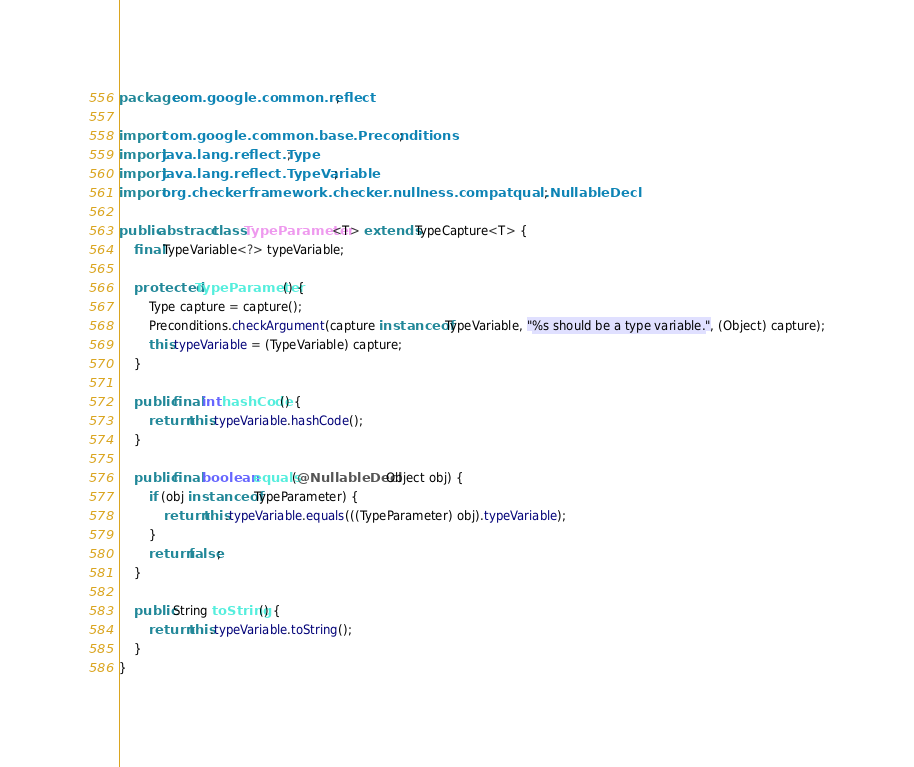<code> <loc_0><loc_0><loc_500><loc_500><_Java_>package com.google.common.reflect;

import com.google.common.base.Preconditions;
import java.lang.reflect.Type;
import java.lang.reflect.TypeVariable;
import org.checkerframework.checker.nullness.compatqual.NullableDecl;

public abstract class TypeParameter<T> extends TypeCapture<T> {
    final TypeVariable<?> typeVariable;

    protected TypeParameter() {
        Type capture = capture();
        Preconditions.checkArgument(capture instanceof TypeVariable, "%s should be a type variable.", (Object) capture);
        this.typeVariable = (TypeVariable) capture;
    }

    public final int hashCode() {
        return this.typeVariable.hashCode();
    }

    public final boolean equals(@NullableDecl Object obj) {
        if (obj instanceof TypeParameter) {
            return this.typeVariable.equals(((TypeParameter) obj).typeVariable);
        }
        return false;
    }

    public String toString() {
        return this.typeVariable.toString();
    }
}
</code> 